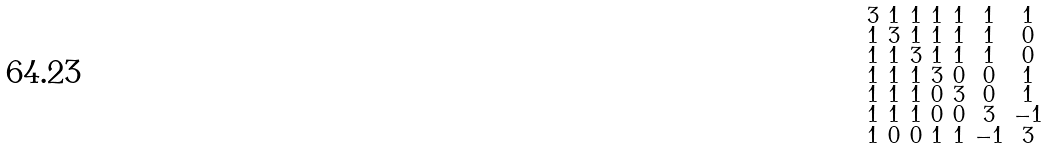<formula> <loc_0><loc_0><loc_500><loc_500>\begin{smallmatrix} 3 & 1 & 1 & 1 & 1 & 1 & 1 \\ 1 & 3 & 1 & 1 & 1 & 1 & 0 \\ 1 & 1 & 3 & 1 & 1 & 1 & 0 \\ 1 & 1 & 1 & 3 & 0 & 0 & 1 \\ 1 & 1 & 1 & 0 & 3 & 0 & 1 \\ 1 & 1 & 1 & 0 & 0 & 3 & - 1 \\ 1 & 0 & 0 & 1 & 1 & - 1 & 3 \end{smallmatrix}</formula> 